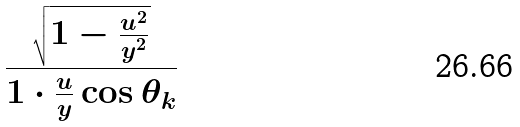<formula> <loc_0><loc_0><loc_500><loc_500>\frac { \sqrt { 1 - \frac { u ^ { 2 } } { y ^ { 2 } } } } { 1 \cdot \frac { u } { y } \cos \theta _ { k } }</formula> 